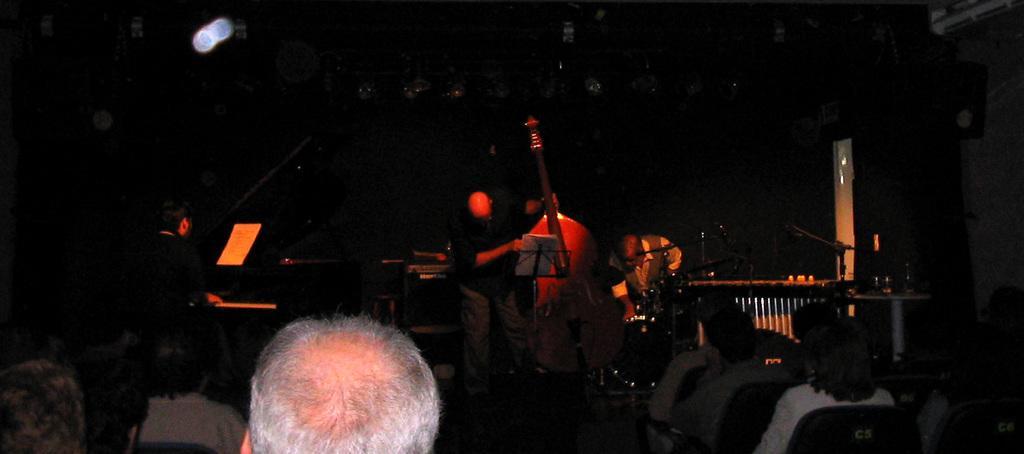Describe this image in one or two sentences. In this picture we can see some people sitting on chairs in the front, in the background there is a man standing and holding a big violin, there is a dark background. 